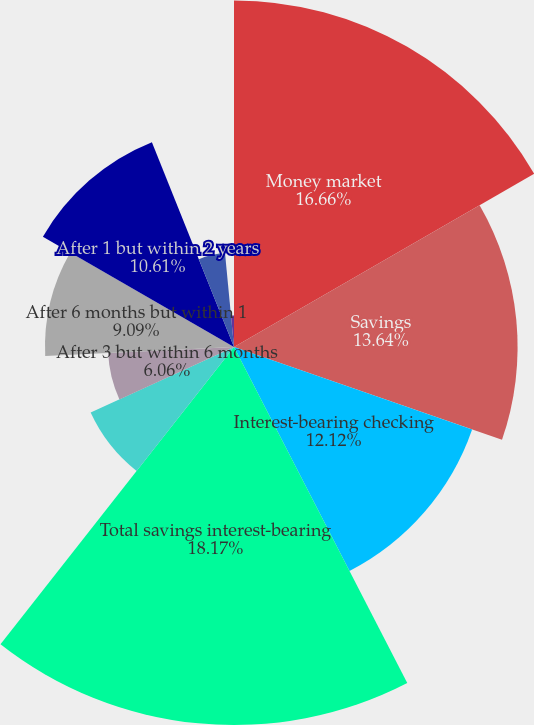Convert chart to OTSL. <chart><loc_0><loc_0><loc_500><loc_500><pie_chart><fcel>Money market<fcel>Savings<fcel>Interest-bearing checking<fcel>Total savings interest-bearing<fcel>Within 3 months<fcel>After 3 but within 6 months<fcel>After 6 months but within 1<fcel>After 1 but within 2 years<fcel>After 2 but within 3 years<fcel>After 3 but within 4 years<nl><fcel>16.67%<fcel>13.64%<fcel>12.12%<fcel>18.18%<fcel>7.58%<fcel>6.06%<fcel>9.09%<fcel>10.61%<fcel>4.55%<fcel>1.52%<nl></chart> 